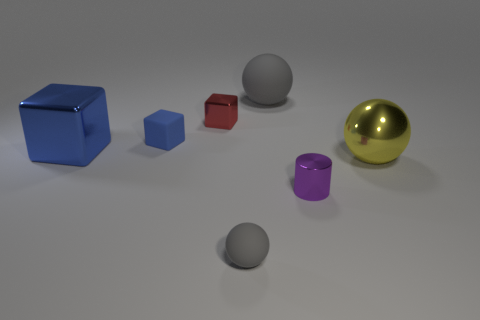Subtract all red cubes. How many cubes are left? 2 Subtract all blue cubes. How many cubes are left? 1 Subtract 1 cylinders. How many cylinders are left? 0 Subtract all cyan blocks. Subtract all red spheres. How many blocks are left? 3 Subtract all brown cylinders. How many yellow cubes are left? 0 Subtract all yellow shiny blocks. Subtract all gray rubber objects. How many objects are left? 5 Add 4 blue rubber objects. How many blue rubber objects are left? 5 Add 7 big blue cubes. How many big blue cubes exist? 8 Add 1 small blue rubber objects. How many objects exist? 8 Subtract 0 red cylinders. How many objects are left? 7 